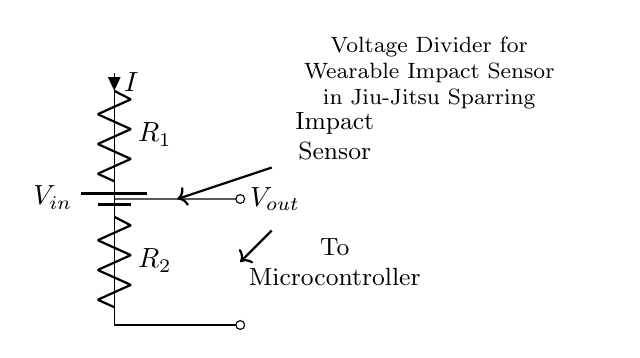What is the input voltage of this circuit? The input voltage is represented by V_in, which is the voltage supplied to the voltage divider circuit.
Answer: V_in What components are used in the voltage divider? The components in the voltage divider are R_1 and R_2, which are resistors that divide the input voltage.
Answer: R_1, R_2 What is the current flowing through R_1? The current flowing through R_1 is indicated by the label I, which shows the current direction through the resistor.
Answer: I What is the purpose of the voltage divider in this circuit? The purpose of the voltage divider is to reduce the input voltage to a lower output voltage (V_out) which can be sent to the microcontroller for processing.
Answer: Reduce voltage How does the output voltage relate to the resistors? The output voltage V_out is determined by the ratio of R_1 and R_2, following the voltage divider formula (V_out = V_in * (R_2 / (R_1 + R_2))).
Answer: Voltage ratio What role does V_out play in the wearable impact sensor? V_out serves as the signal that represents the force distribution from the impact sensor, which is analyzed by the microcontroller during sparring.
Answer: Signal to microcontroller How do R_1 and R_2 affect the output voltage? R_1 and R_2 affect the output voltage through their resistance values; increasing R_2 or decreasing R_1 raises V_out, while vice versa would lower it.
Answer: Affect voltage 